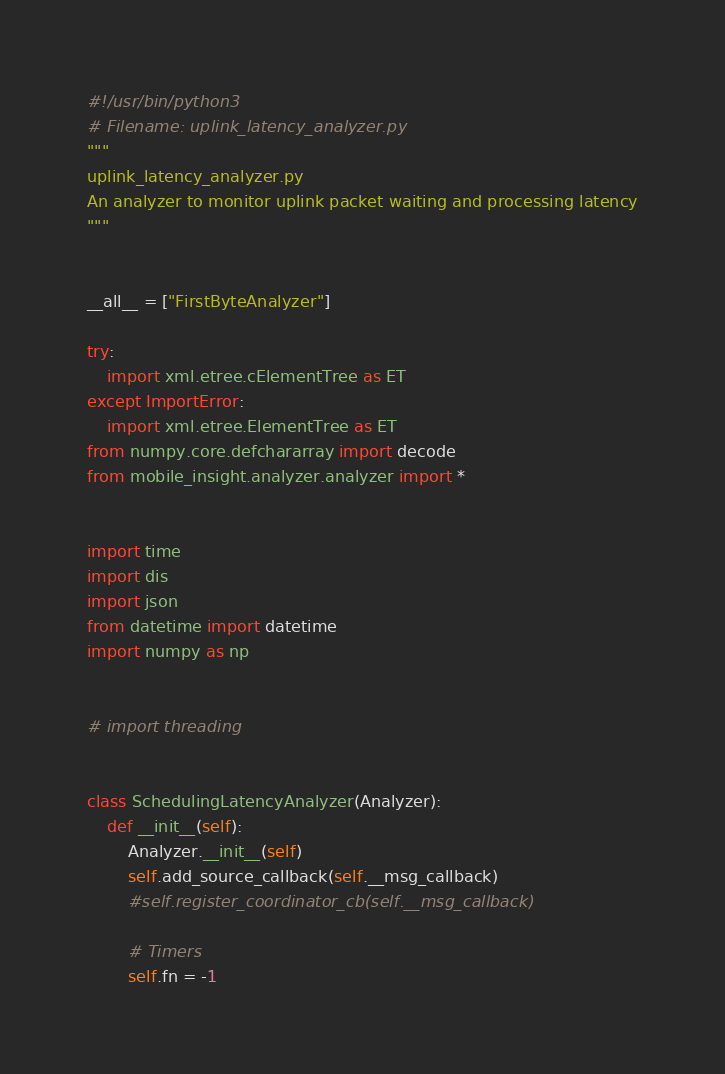<code> <loc_0><loc_0><loc_500><loc_500><_Python_>#!/usr/bin/python3
# Filename: uplink_latency_analyzer.py
"""
uplink_latency_analyzer.py
An analyzer to monitor uplink packet waiting and processing latency
"""


__all__ = ["FirstByteAnalyzer"]

try:
    import xml.etree.cElementTree as ET
except ImportError:
    import xml.etree.ElementTree as ET
from numpy.core.defchararray import decode
from mobile_insight.analyzer.analyzer import *


import time
import dis
import json
from datetime import datetime
import numpy as np


# import threading


class SchedulingLatencyAnalyzer(Analyzer):
    def __init__(self):
        Analyzer.__init__(self)
        self.add_source_callback(self.__msg_callback)
        #self.register_coordinator_cb(self.__msg_callback)

        # Timers 
        self.fn = -1</code> 